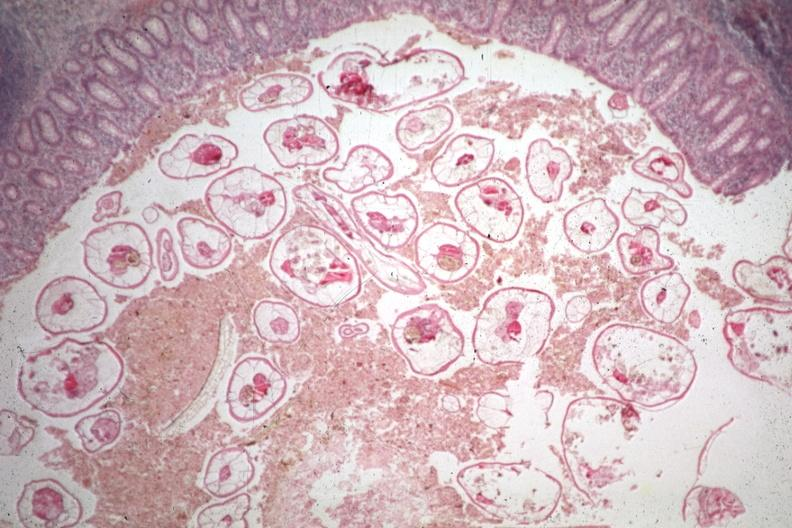what is present?
Answer the question using a single word or phrase. Gastrointestinal 